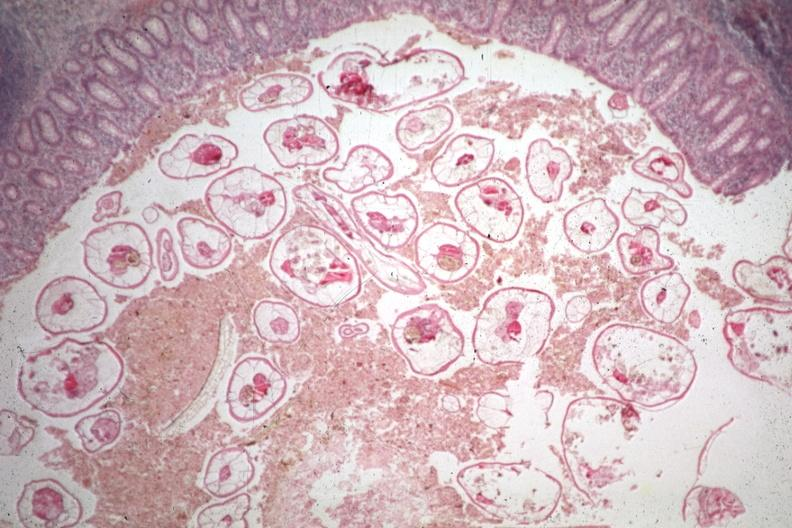what is present?
Answer the question using a single word or phrase. Gastrointestinal 